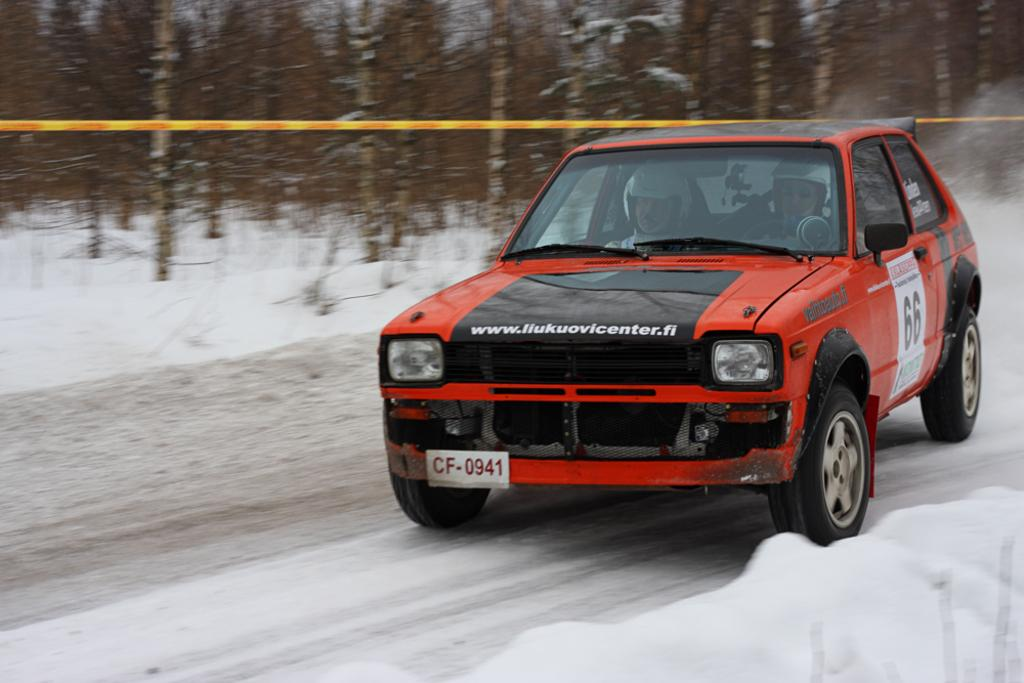What is the main subject in the foreground of the image? There is a car in the foreground of the image. Where is the car located? The car is on the road. What can be seen in the background of the image? There are trees and ice visible in the background of the image. Can you tell if the image was taken during the day or night? Yes, the image was likely taken during the day, as there is enough light to see the details clearly. What type of verse is being recited by the robin in the image? There is no robin present in the image, and therefore no verse being recited. must be polite and professional when saying it isn't present in the image. 